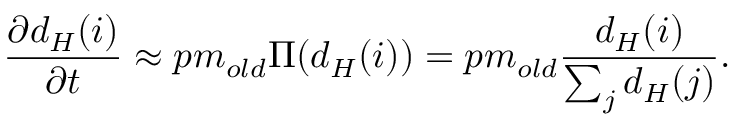Convert formula to latex. <formula><loc_0><loc_0><loc_500><loc_500>\frac { \partial d _ { H } ( i ) } { \partial t } \approx p m _ { o l d } \Pi ( d _ { H } ( i ) ) = p m _ { o l d } \frac { d _ { H } ( i ) } { \sum _ { j } d _ { H } ( j ) } .</formula> 